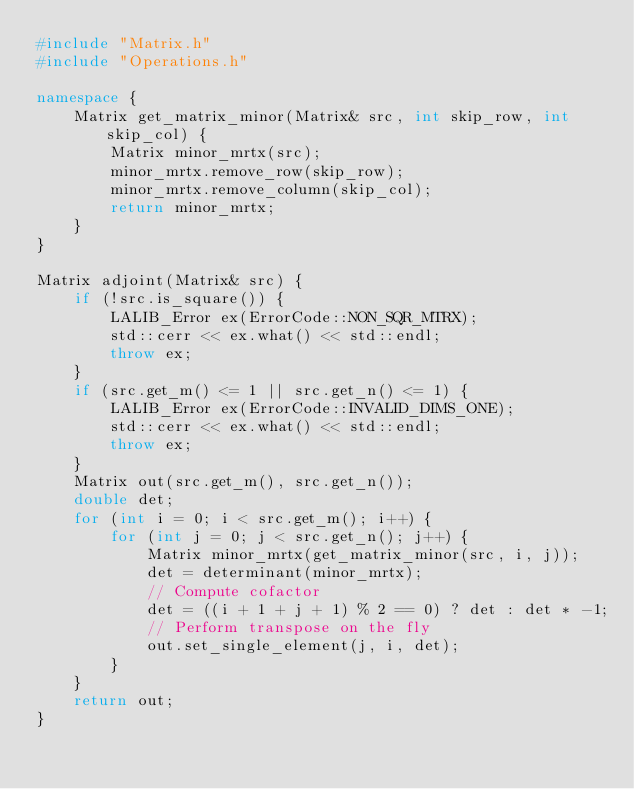Convert code to text. <code><loc_0><loc_0><loc_500><loc_500><_C++_>#include "Matrix.h"
#include "Operations.h"

namespace {
    Matrix get_matrix_minor(Matrix& src, int skip_row, int skip_col) {
		Matrix minor_mrtx(src);
		minor_mrtx.remove_row(skip_row);
		minor_mrtx.remove_column(skip_col);
		return minor_mrtx;
	}
}

Matrix adjoint(Matrix& src) {
    if (!src.is_square()) {
		LALIB_Error ex(ErrorCode::NON_SQR_MTRX);
		std::cerr << ex.what() << std::endl;
		throw ex;
	}
	if (src.get_m() <= 1 || src.get_n() <= 1) {
		LALIB_Error ex(ErrorCode::INVALID_DIMS_ONE);
		std::cerr << ex.what() << std::endl;
		throw ex;
	}
    Matrix out(src.get_m(), src.get_n());
    double det;
    for (int i = 0; i < src.get_m(); i++) {
	    for (int j = 0; j < src.get_n(); j++) {
            Matrix minor_mrtx(get_matrix_minor(src, i, j));
            det = determinant(minor_mrtx);
            // Compute cofactor
            det = ((i + 1 + j + 1) % 2 == 0) ? det : det * -1;
            // Perform transpose on the fly
            out.set_single_element(j, i, det);
        }
    }
    return out;
}</code> 